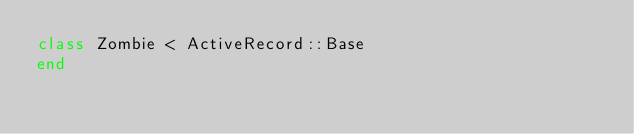Convert code to text. <code><loc_0><loc_0><loc_500><loc_500><_Ruby_>class Zombie < ActiveRecord::Base
end
</code> 